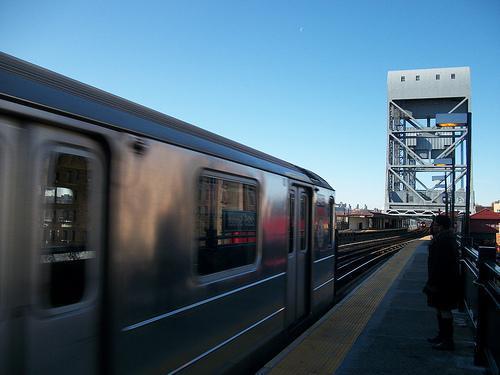How many window panes are in a door?
Give a very brief answer. 3. 